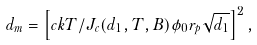<formula> <loc_0><loc_0><loc_500><loc_500>d _ { m } = \left [ c k T / J _ { c } ( d _ { 1 } , T , B ) \phi _ { 0 } r _ { p } \sqrt { d _ { 1 } } \right ] ^ { 2 } ,</formula> 